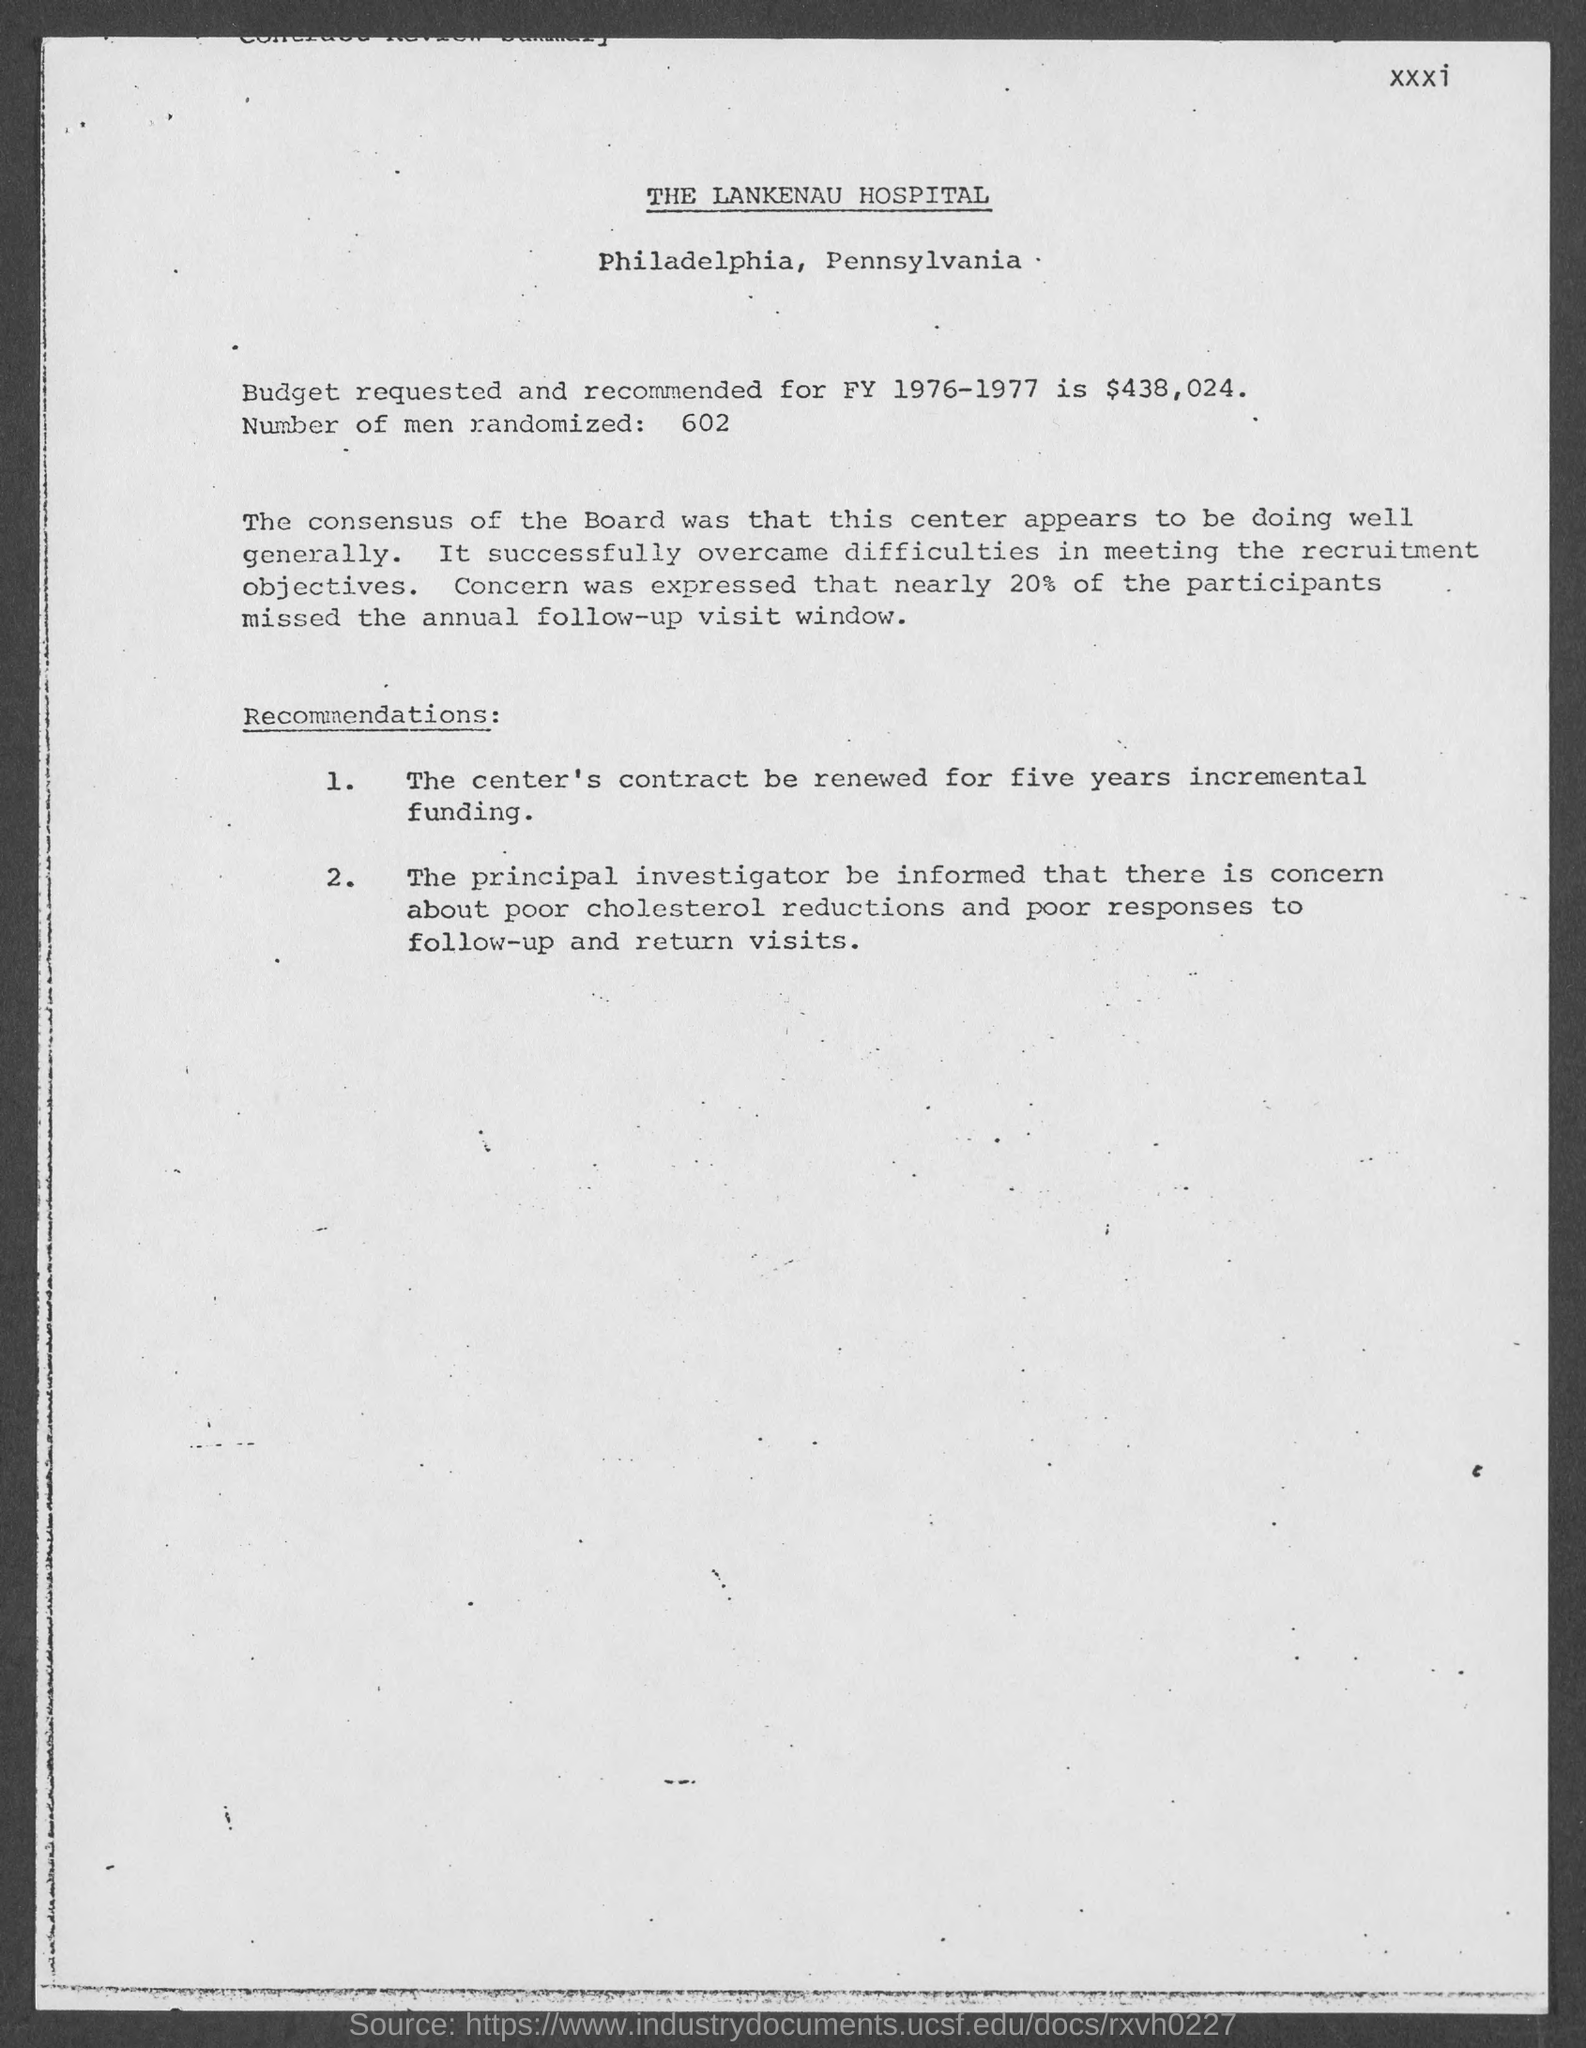What is the budget requested and recommended  fy 1976-1977 ?
Your answer should be compact. $438,024. How many number of men are randomized ?
Keep it short and to the point. 602. In which county is the lankenau hospital at ?
Provide a short and direct response. Philadelphia. 